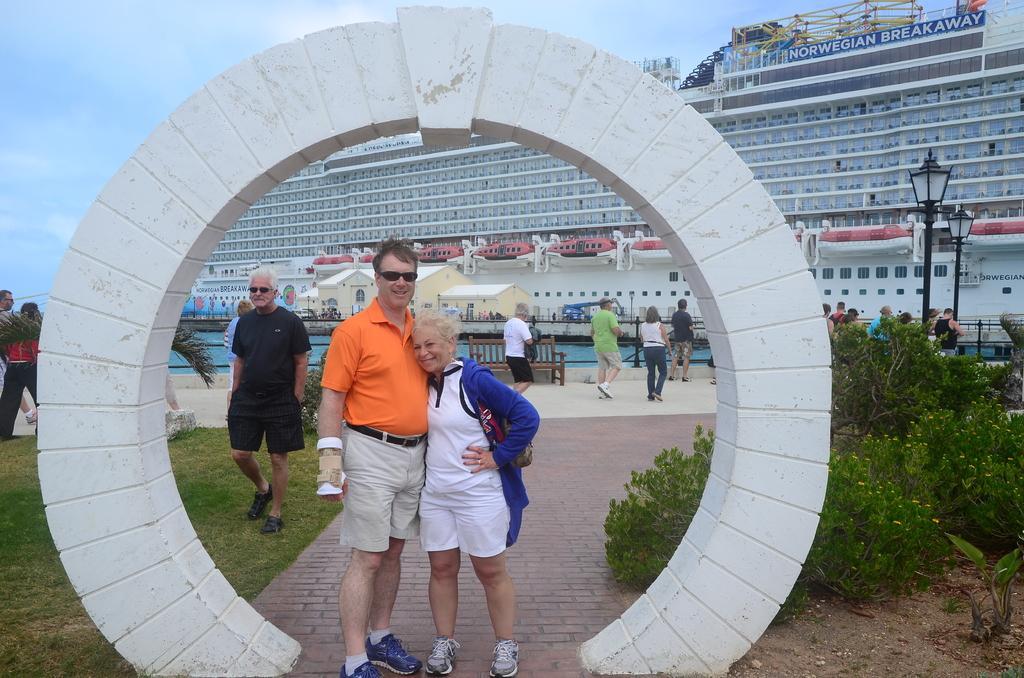Could you give a brief overview of what you see in this image? In this picture we two people who are posing for a picture and over their head there is an white Arch and in the background we observe a huge building on which we observe a NORWEGIAN BREAKAWAY. 